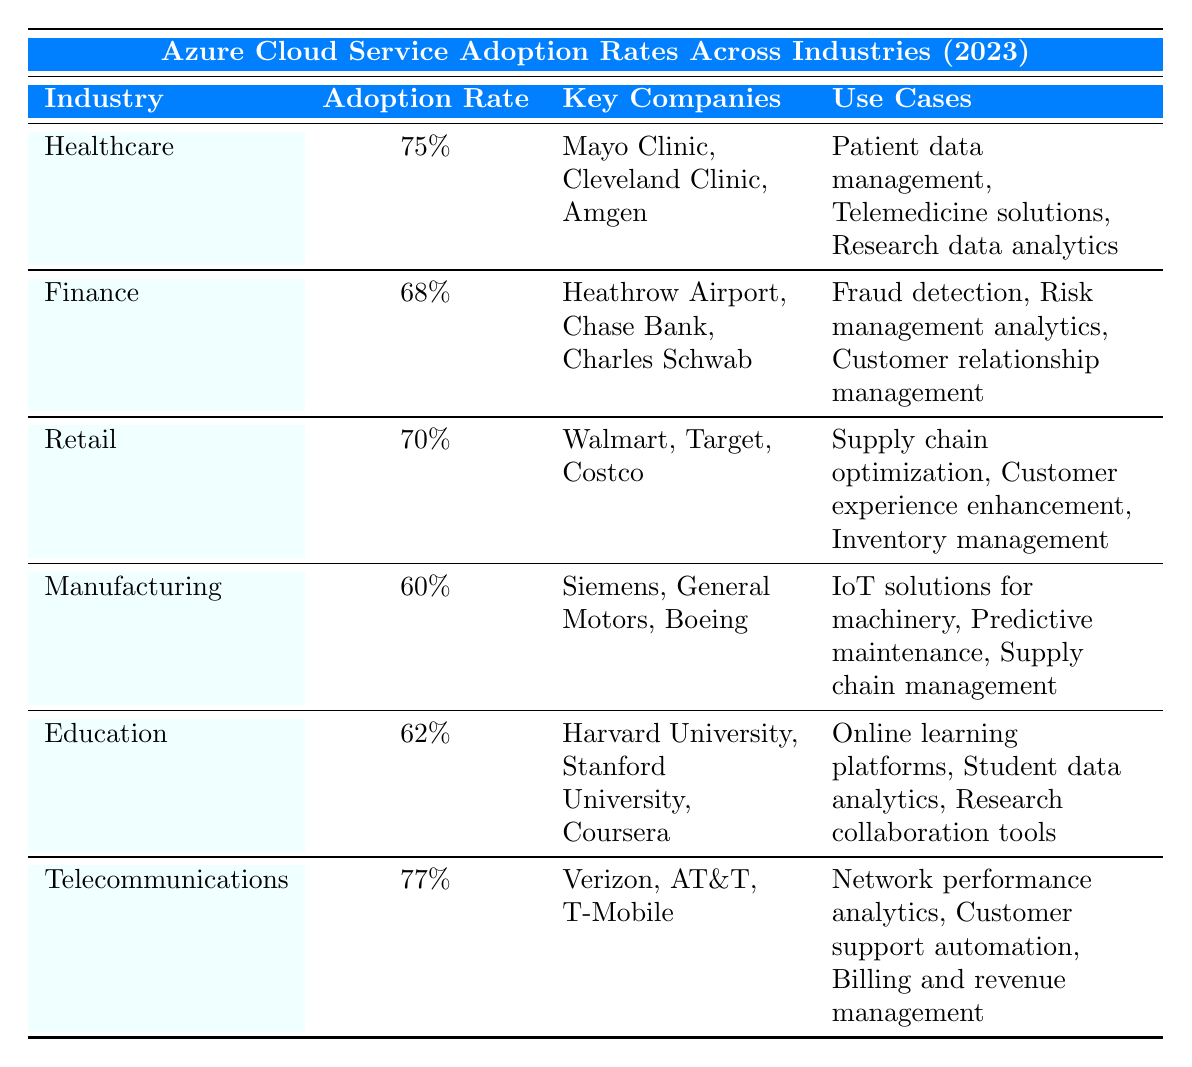What is the highest adoption rate for Azure in a specific industry? The table shows the adoption rates for various industries, and the highest is in Telecommunications at 77%.
Answer: 77% Which industry has the lowest adoption rate for Azure? By checking the adoption rates in the table, Manufacturing has the lowest adoption rate at 60%.
Answer: 60% List one key company in the Healthcare industry utilizing Azure. The table lists key companies for each industry, with one from Healthcare being Mayo Clinic.
Answer: Mayo Clinic What is the adoption rate of the Finance industry? The Finance industry is listed in the table with an adoption rate of 68%.
Answer: 68% Which industry has more adoption, Retail or Education? Comparing the two industries, Retail has a rate of 70% while Education has 62%, so Retail has more adoption.
Answer: Retail How many use cases are listed for the Manufacturing industry? The table shows three use cases for Manufacturing: IoT solutions for machinery, Predictive maintenance, and Supply chain management.
Answer: 3 True or False: Amgen is a key company in the Finance industry. Amgen is listed as a key company in the Healthcare industry in the table, so the statement is false.
Answer: False What is the average adoption rate of Azure across the listed industries? Adding the adoption rates (75 + 68 + 70 + 60 + 62 + 77 = 412) and dividing by the number of industries (6), we get an average of 412 / 6 = 68.67%.
Answer: 68.67% Identify an industry that uses Azure for customer experience enhancement. The Retail industry in the table uses Azure for customer experience enhancement.
Answer: Retail How does the adoption rate of Healthcare compare to that of Manufacturing? Healthcare has an adoption rate of 75% which is 15% higher than Manufacturing's 60% rate.
Answer: 15% higher Which industry utilizes Azure for research data analytics? The Healthcare industry is the one that uses Azure for research data analytics, as listed in its use cases.
Answer: Healthcare 